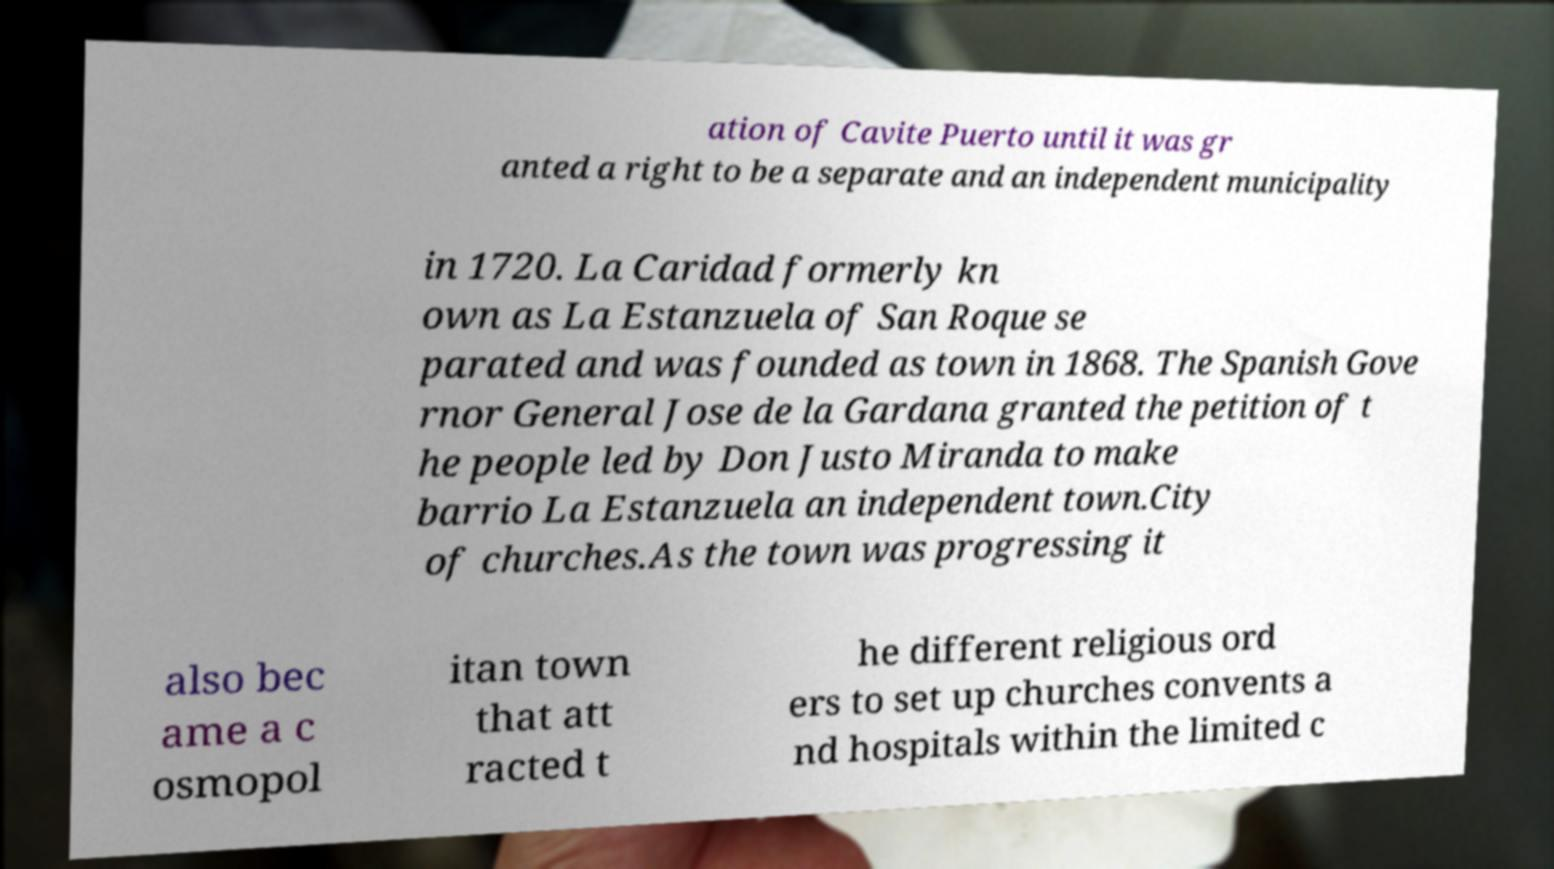Please identify and transcribe the text found in this image. ation of Cavite Puerto until it was gr anted a right to be a separate and an independent municipality in 1720. La Caridad formerly kn own as La Estanzuela of San Roque se parated and was founded as town in 1868. The Spanish Gove rnor General Jose de la Gardana granted the petition of t he people led by Don Justo Miranda to make barrio La Estanzuela an independent town.City of churches.As the town was progressing it also bec ame a c osmopol itan town that att racted t he different religious ord ers to set up churches convents a nd hospitals within the limited c 